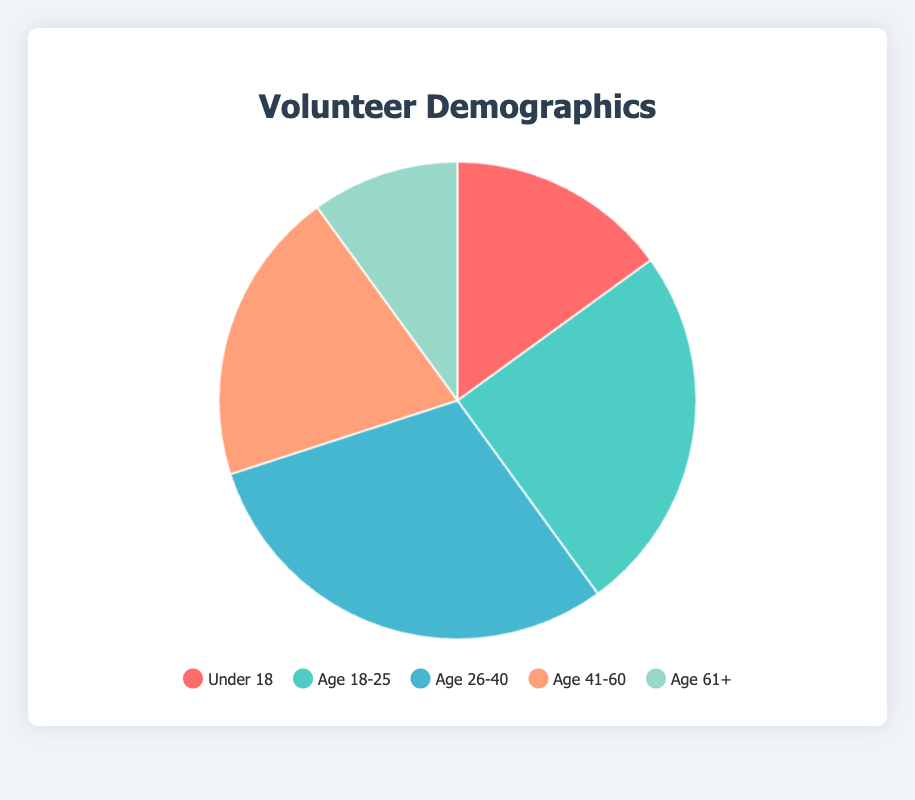What age group has the highest percentage of volunteers? The age group "Age 26-40" has 30 volunteers, which is the highest number among the groups. By inspecting the segments of the pie chart and their sizes, it is clear this group represents the largest proportion.
Answer: Age 26-40 Which age group has the smallest representation in the volunteer demographics? The segment for "Age 61+" represents the smallest number of volunteers, consisting of 10 individuals. When comparing the slices, this segment is visually the smallest.
Answer: Age 61+ How many more volunteers are there in the 26-40 age group compared to the 61+ age group? The 26-40 age group has 30 volunteers, while the 61+ age group has 10. The difference is calculated as 30 - 10 = 20.
Answer: 20 What percentage of the total volunteers are under 18? To find the percentage, divide the number of volunteers under 18 by the total number of volunteers, then multiply by 100. The calculation is (15 / (15 + 25 + 30 + 20 + 10)) * 100 = (15 / 100) * 100 = 15%.
Answer: 15% If the total number of volunteers is 100, how many volunteers are between the ages of 18 and 25 and between 41 and 60 combined? Sum the number of volunteers in the two groups: 25 (Age 18-25) + 20 (Age 41-60) = 45.
Answer: 45 What is the ratio of volunteers in the Age 26-40 group to those in the Under 18 group? The number of volunteers in Age 26-40 is 30, and Under 18 is 15. The ratio is 30:15, which simplifies to 2:1.
Answer: 2:1 Which age group contributes to a quarter of the volunteer demographic? The Age 18-25 group has 25 volunteers. By calculating (25 / 100) * 100, it is apparent this group makes up 25% of the total.
Answer: Age 18-25 How does the size of the Age 18-25 segment compare to the size of the Age 41-60 segment? The Age 18-25 group has 25 volunteers compared to the Age 41-60 group’s 20. Since 25 is greater than 20, the Age 18-25 segment is visually larger on the pie chart.
Answer: Larger What percentage of the total volunteers are age 41+? Combine the volunteers in Age 41-60 and Age 61+ groups: 20 (Age 41-60) + 10 (Age 61+) = 30. Calculate the percentage: (30 / 100) * 100 = 30%.
Answer: 30% Based on the colors of the pie chart, which color represents the Age 26-40 group? The chart configuration specifies the order and corresponding colors. For Age 26-40, which is the third group, the color is blue.
Answer: Blue 